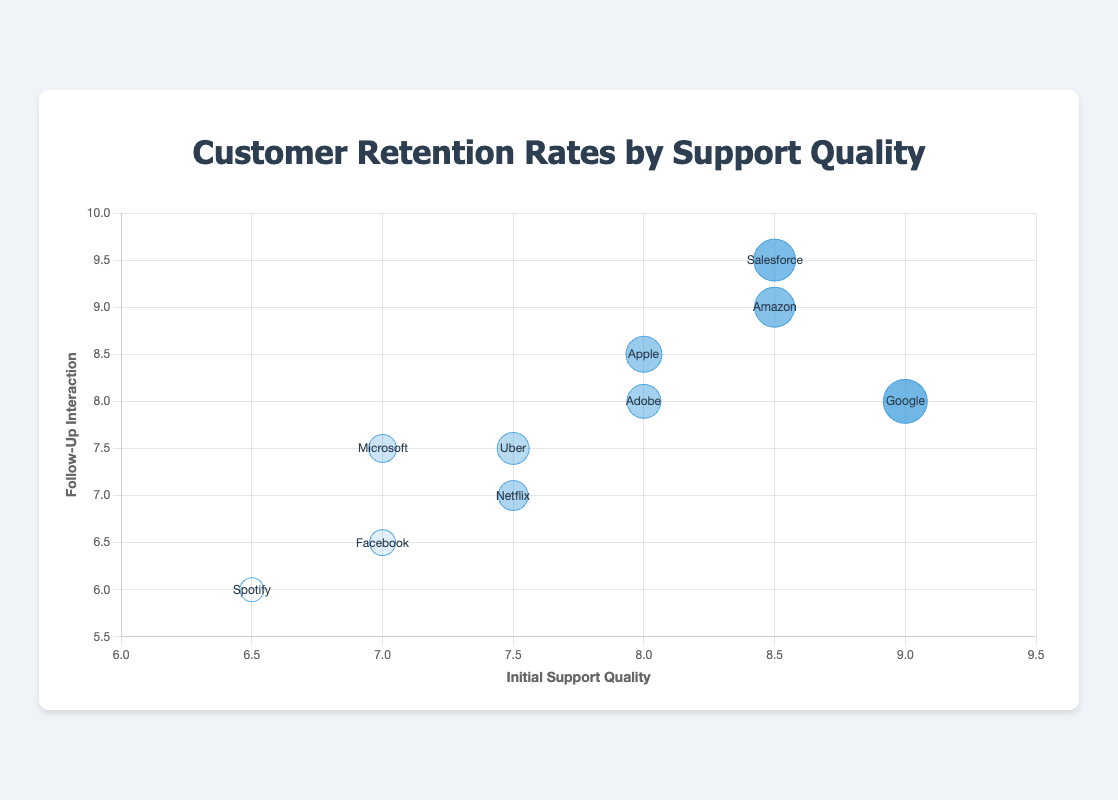What's the title of the chart? The title is typically located at the top of the chart. Here, the title is given directly as "Customer Retention Rates by Support Quality" based on the provided code.
Answer: Customer Retention Rates by Support Quality Which company has the highest customer retention rate, and what is their rate? By examining the bubbles and their corresponding retention rates, we can see that Google has the highest retention rate, which is 94.
Answer: Google, 94 Which two companies have the lowest initial support quality scores, and what are their scores? Spotify and Facebook have the lowest initial support quality scores, which are 6.5 and 7, respectively. These values are on the x-axis.
Answer: Spotify (6.5) and Facebook (7) What is the average follow-up interaction score of Amazon and Salesforce? We need to find the follow-up interaction scores of Amazon and Salesforce, which are 9 and 9.5, respectively. The average of these two numbers is (9 + 9.5) / 2 = 9.25.
Answer: 9.25 Compare the customer retention rates between Amazon and Uber. Which company has the higher rate, and what is the difference? Amazon has a customer retention rate of 92, and Uber has 87. The difference is 92 - 87 = 5. Thus, Amazon has the higher rate by 5.
Answer: Amazon, 5 What is the relationship between initial support quality and customer retention rate for Apple and Netflix? Apple's initial support quality is 8, with a retention rate of 90. Netflix has a support quality of 7.5 and a retention rate of 88. By comparing both, a higher support quality correlates with a higher retention rate for these two companies.
Answer: Higher support quality correlates with higher retention rate Which company has a follow-up interaction score equal to its initial support quality, and what is the score? Uber has both initial support quality and follow-up interaction scores at 7.5, as indicated in the data points.
Answer: Uber, 7.5 What is the average customer retention rate across all companies? We need to sum up all the customer retention rates (92+88+90+94+85+80+83+93+89+87 = 881) and divide by the number of companies (10). The average is 881 / 10 = 88.1.
Answer: 88.1 Which company's bubble is the largest on the chart, and what is its size? Google has the largest bubble size with a value of 22, as indicated in the data.
Answer: Google, 22 